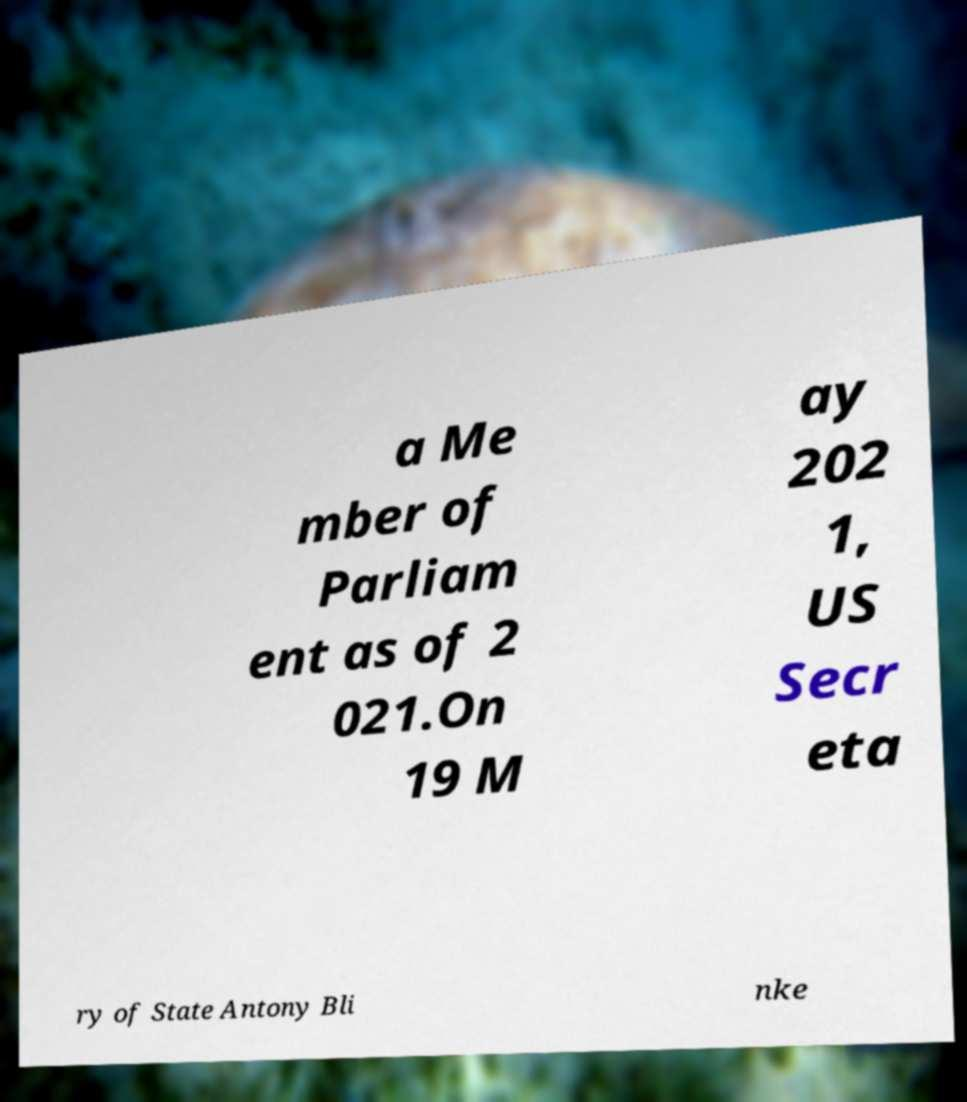There's text embedded in this image that I need extracted. Can you transcribe it verbatim? a Me mber of Parliam ent as of 2 021.On 19 M ay 202 1, US Secr eta ry of State Antony Bli nke 